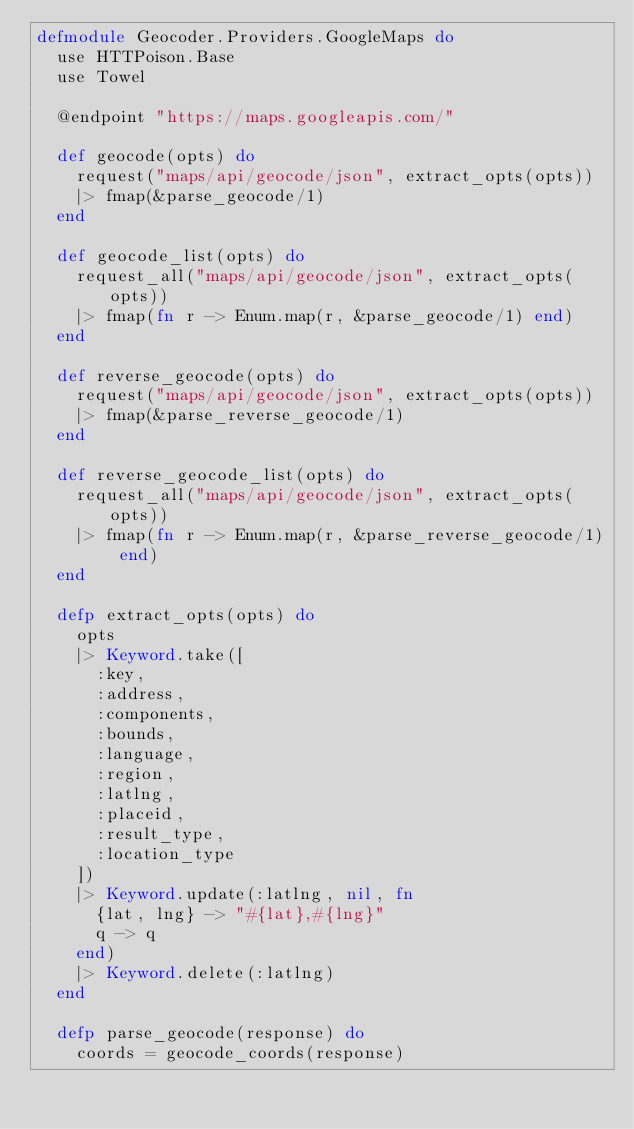<code> <loc_0><loc_0><loc_500><loc_500><_Elixir_>defmodule Geocoder.Providers.GoogleMaps do
  use HTTPoison.Base
  use Towel

  @endpoint "https://maps.googleapis.com/"

  def geocode(opts) do
    request("maps/api/geocode/json", extract_opts(opts))
    |> fmap(&parse_geocode/1)
  end

  def geocode_list(opts) do
    request_all("maps/api/geocode/json", extract_opts(opts))
    |> fmap(fn r -> Enum.map(r, &parse_geocode/1) end)
  end

  def reverse_geocode(opts) do
    request("maps/api/geocode/json", extract_opts(opts))
    |> fmap(&parse_reverse_geocode/1)
  end

  def reverse_geocode_list(opts) do
    request_all("maps/api/geocode/json", extract_opts(opts))
    |> fmap(fn r -> Enum.map(r, &parse_reverse_geocode/1) end)
  end

  defp extract_opts(opts) do
    opts
    |> Keyword.take([
      :key,
      :address,
      :components,
      :bounds,
      :language,
      :region,
      :latlng,
      :placeid,
      :result_type,
      :location_type
    ])
    |> Keyword.update(:latlng, nil, fn
      {lat, lng} -> "#{lat},#{lng}"
      q -> q
    end)
    |> Keyword.delete(:latlng)
  end

  defp parse_geocode(response) do
    coords = geocode_coords(response)</code> 